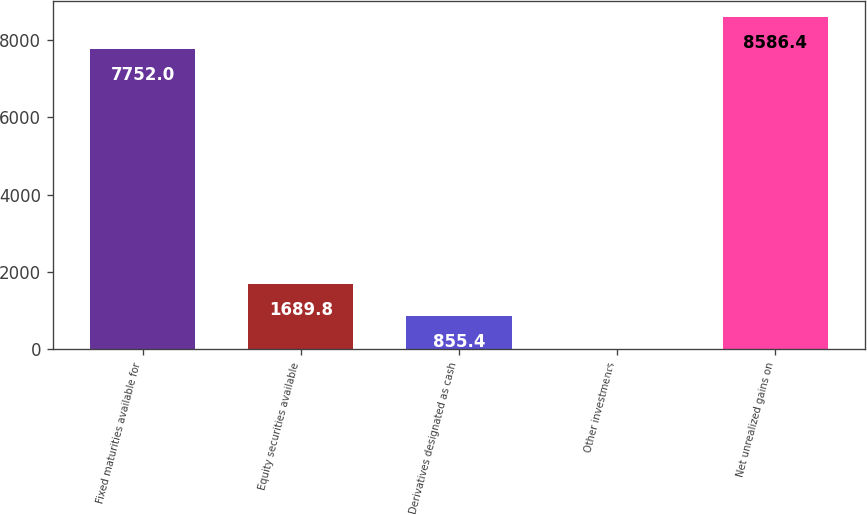<chart> <loc_0><loc_0><loc_500><loc_500><bar_chart><fcel>Fixed maturities available for<fcel>Equity securities available<fcel>Derivatives designated as cash<fcel>Other investments<fcel>Net unrealized gains on<nl><fcel>7752<fcel>1689.8<fcel>855.4<fcel>21<fcel>8586.4<nl></chart> 